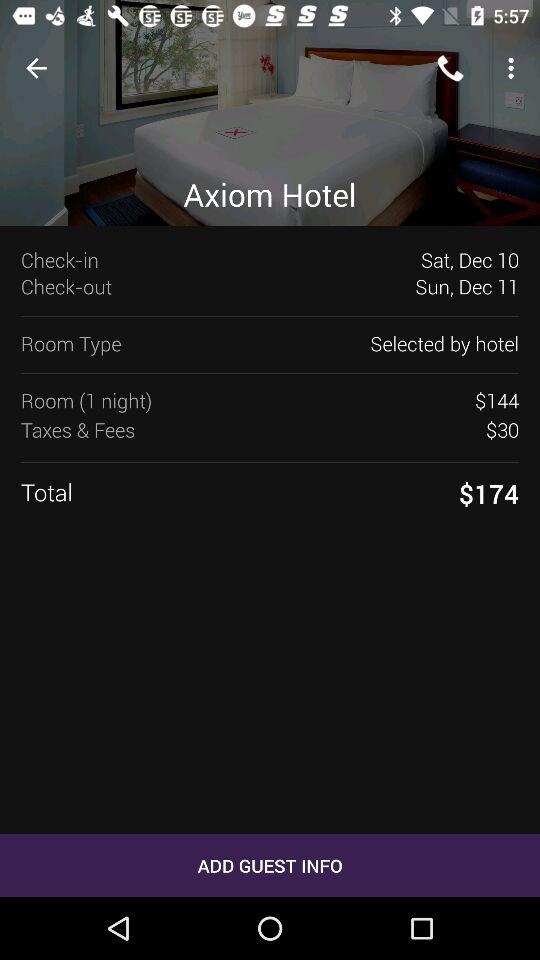How much more is the total than the room price?
Answer the question using a single word or phrase. $30 